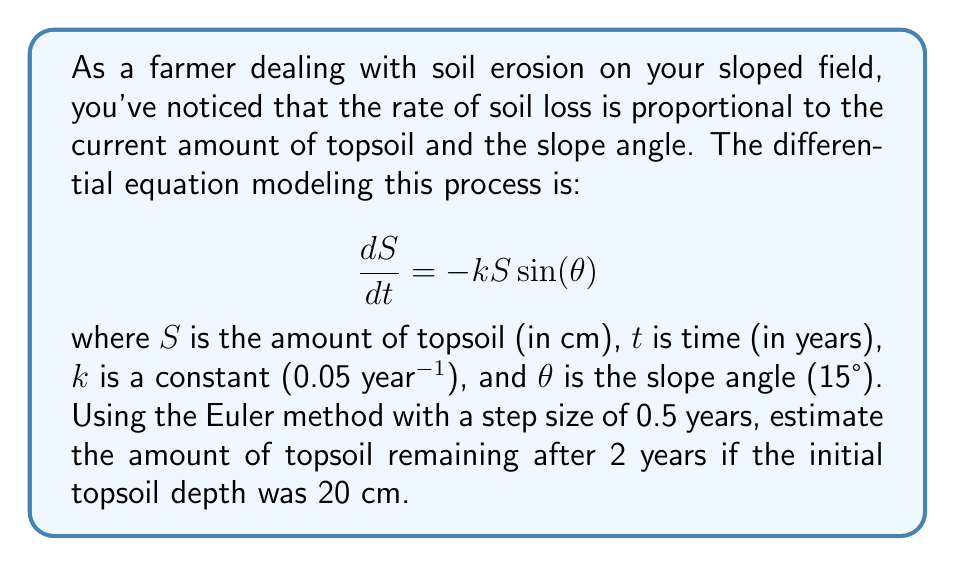Solve this math problem. Let's solve this problem step-by-step using the Euler method:

1) The Euler method is given by the formula:
   $$S_{n+1} = S_n + h \cdot f(t_n, S_n)$$
   where $h$ is the step size and $f(t, S) = -kS\sin(\theta)$

2) Given information:
   - Initial topsoil depth $S_0 = 20$ cm
   - $k = 0.05$ year$^{-1}$
   - $\theta = 15°$
   - Step size $h = 0.5$ years
   - We need to calculate for 2 years, so we'll need 4 steps

3) Calculate $\sin(\theta)$:
   $\sin(15°) \approx 0.2588$

4) Our function $f(t, S)$ becomes:
   $f(t, S) = -0.05 \cdot S \cdot 0.2588 = -0.01294S$

5) Now let's apply the Euler method:

   Step 1 ($t = 0.5$):
   $S_1 = S_0 + h \cdot f(t_0, S_0) = 20 + 0.5 \cdot (-0.01294 \cdot 20) = 19.8706$ cm

   Step 2 ($t = 1.0$):
   $S_2 = S_1 + h \cdot f(t_1, S_1) = 19.8706 + 0.5 \cdot (-0.01294 \cdot 19.8706) = 19.7422$ cm

   Step 3 ($t = 1.5$):
   $S_3 = S_2 + h \cdot f(t_2, S_2) = 19.7422 + 0.5 \cdot (-0.01294 \cdot 19.7422) = 19.6149$ cm

   Step 4 ($t = 2.0$):
   $S_4 = S_3 + h \cdot f(t_3, S_3) = 19.6149 + 0.5 \cdot (-0.01294 \cdot 19.6149) = 19.4886$ cm

6) Therefore, after 2 years, the estimated amount of topsoil remaining is approximately 19.4886 cm.
Answer: 19.4886 cm 